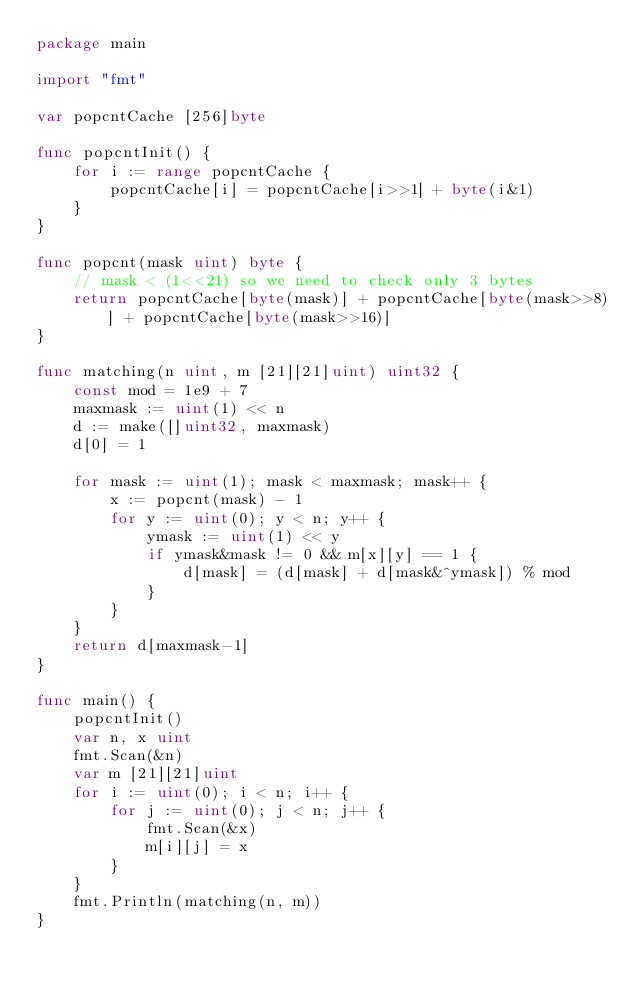<code> <loc_0><loc_0><loc_500><loc_500><_Go_>package main

import "fmt"

var popcntCache [256]byte

func popcntInit() {
	for i := range popcntCache {
		popcntCache[i] = popcntCache[i>>1] + byte(i&1)
	}
}

func popcnt(mask uint) byte {
	// mask < (1<<21) so we need to check only 3 bytes
	return popcntCache[byte(mask)] + popcntCache[byte(mask>>8)] + popcntCache[byte(mask>>16)]
}

func matching(n uint, m [21][21]uint) uint32 {
	const mod = 1e9 + 7
	maxmask := uint(1) << n
	d := make([]uint32, maxmask)
	d[0] = 1

	for mask := uint(1); mask < maxmask; mask++ {
		x := popcnt(mask) - 1
		for y := uint(0); y < n; y++ {
			ymask := uint(1) << y
			if ymask&mask != 0 && m[x][y] == 1 {
				d[mask] = (d[mask] + d[mask&^ymask]) % mod
			}
		}
	}
	return d[maxmask-1]
}

func main() {
	popcntInit()
	var n, x uint
	fmt.Scan(&n)
	var m [21][21]uint
	for i := uint(0); i < n; i++ {
		for j := uint(0); j < n; j++ {
			fmt.Scan(&x)
			m[i][j] = x
		}
	}
	fmt.Println(matching(n, m))
}
</code> 